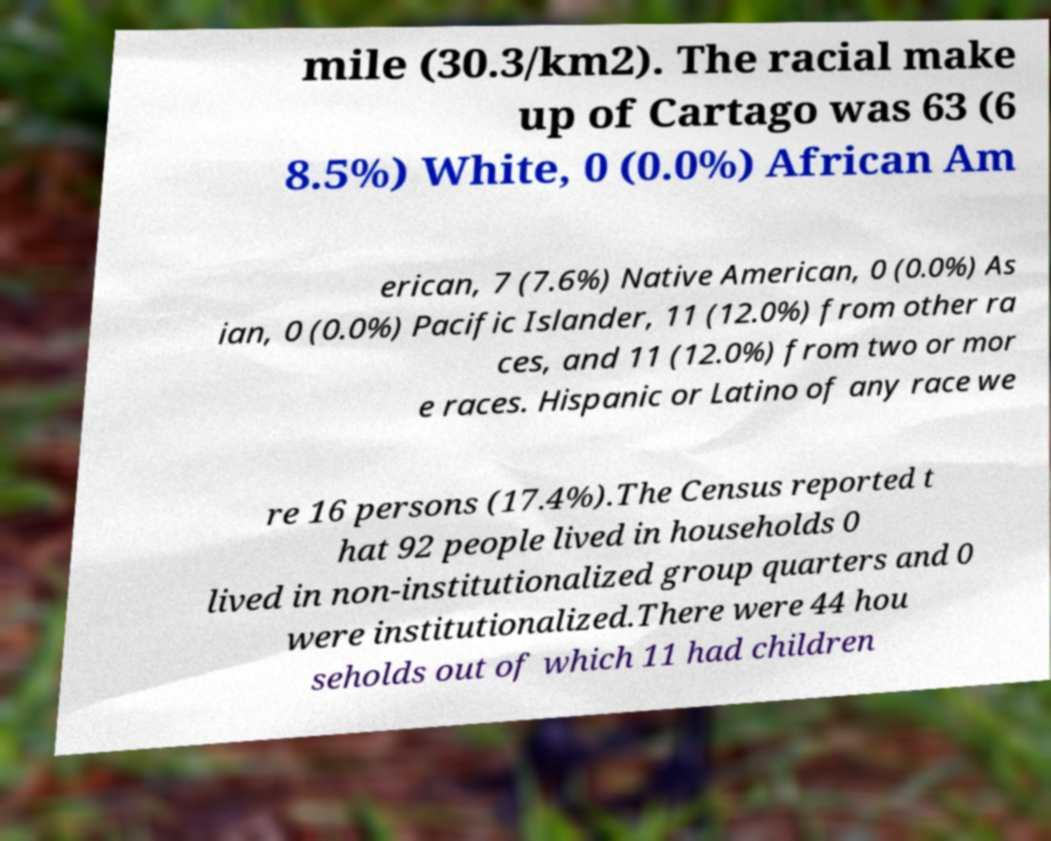Please identify and transcribe the text found in this image. mile (30.3/km2). The racial make up of Cartago was 63 (6 8.5%) White, 0 (0.0%) African Am erican, 7 (7.6%) Native American, 0 (0.0%) As ian, 0 (0.0%) Pacific Islander, 11 (12.0%) from other ra ces, and 11 (12.0%) from two or mor e races. Hispanic or Latino of any race we re 16 persons (17.4%).The Census reported t hat 92 people lived in households 0 lived in non-institutionalized group quarters and 0 were institutionalized.There were 44 hou seholds out of which 11 had children 